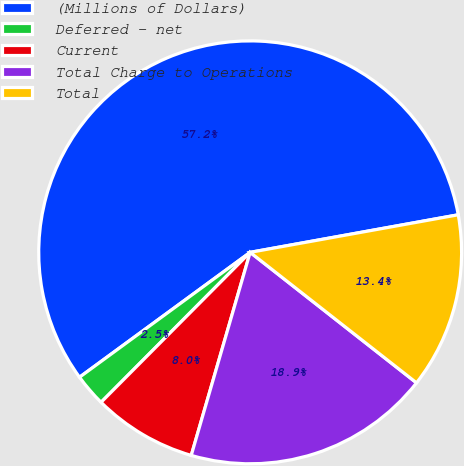Convert chart to OTSL. <chart><loc_0><loc_0><loc_500><loc_500><pie_chart><fcel>(Millions of Dollars)<fcel>Deferred - net<fcel>Current<fcel>Total Charge to Operations<fcel>Total<nl><fcel>57.22%<fcel>2.49%<fcel>7.96%<fcel>18.91%<fcel>13.43%<nl></chart> 